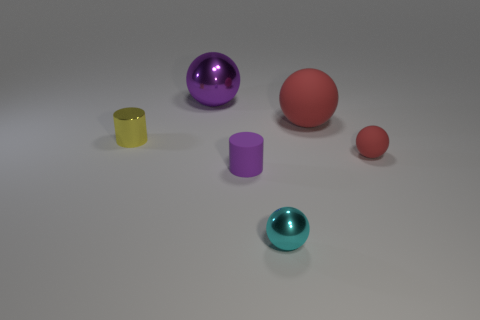Are there any tiny cylinders that are right of the sphere left of the rubber thing that is on the left side of the large red rubber thing? Upon observing the image, one can affirmatively state that there are indeed tiny cylinders situated to the right of the sphere. More specifically, looking to the left of the rubber object, one can identify a tiny yellow cylinder positioned to the right of a purple sphere, both of which are found on the left side of a large red sphere that exhibits rubber-like characteristics. 